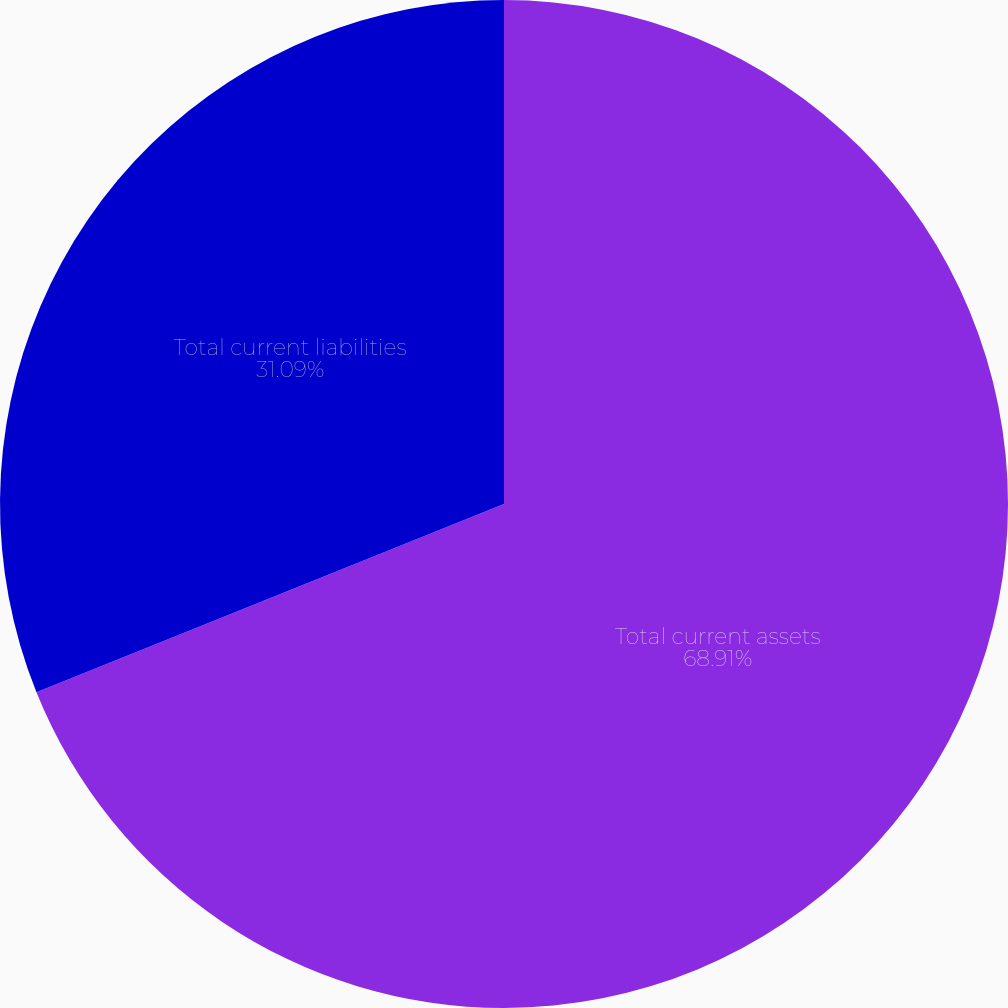<chart> <loc_0><loc_0><loc_500><loc_500><pie_chart><fcel>Total current assets<fcel>Total current liabilities<nl><fcel>68.91%<fcel>31.09%<nl></chart> 